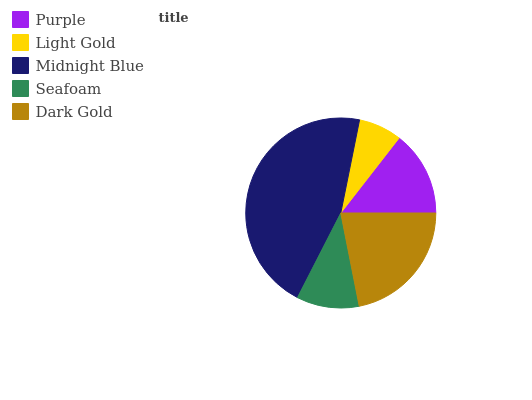Is Light Gold the minimum?
Answer yes or no. Yes. Is Midnight Blue the maximum?
Answer yes or no. Yes. Is Midnight Blue the minimum?
Answer yes or no. No. Is Light Gold the maximum?
Answer yes or no. No. Is Midnight Blue greater than Light Gold?
Answer yes or no. Yes. Is Light Gold less than Midnight Blue?
Answer yes or no. Yes. Is Light Gold greater than Midnight Blue?
Answer yes or no. No. Is Midnight Blue less than Light Gold?
Answer yes or no. No. Is Purple the high median?
Answer yes or no. Yes. Is Purple the low median?
Answer yes or no. Yes. Is Light Gold the high median?
Answer yes or no. No. Is Midnight Blue the low median?
Answer yes or no. No. 